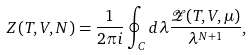Convert formula to latex. <formula><loc_0><loc_0><loc_500><loc_500>Z ( T , V , N ) = \frac { 1 } { 2 \pi i } \oint _ { C } d \lambda \frac { \mathcal { Z } ( T , V , \mu ) } { \lambda ^ { N + 1 } } ,</formula> 